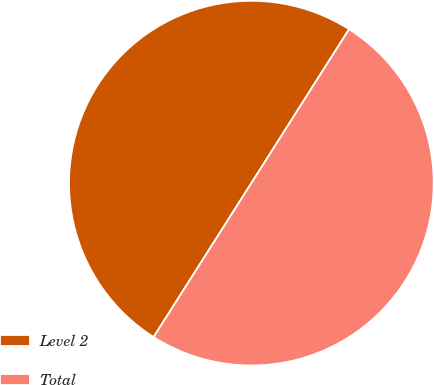Convert chart. <chart><loc_0><loc_0><loc_500><loc_500><pie_chart><fcel>Level 2<fcel>Total<nl><fcel>50.0%<fcel>50.0%<nl></chart> 